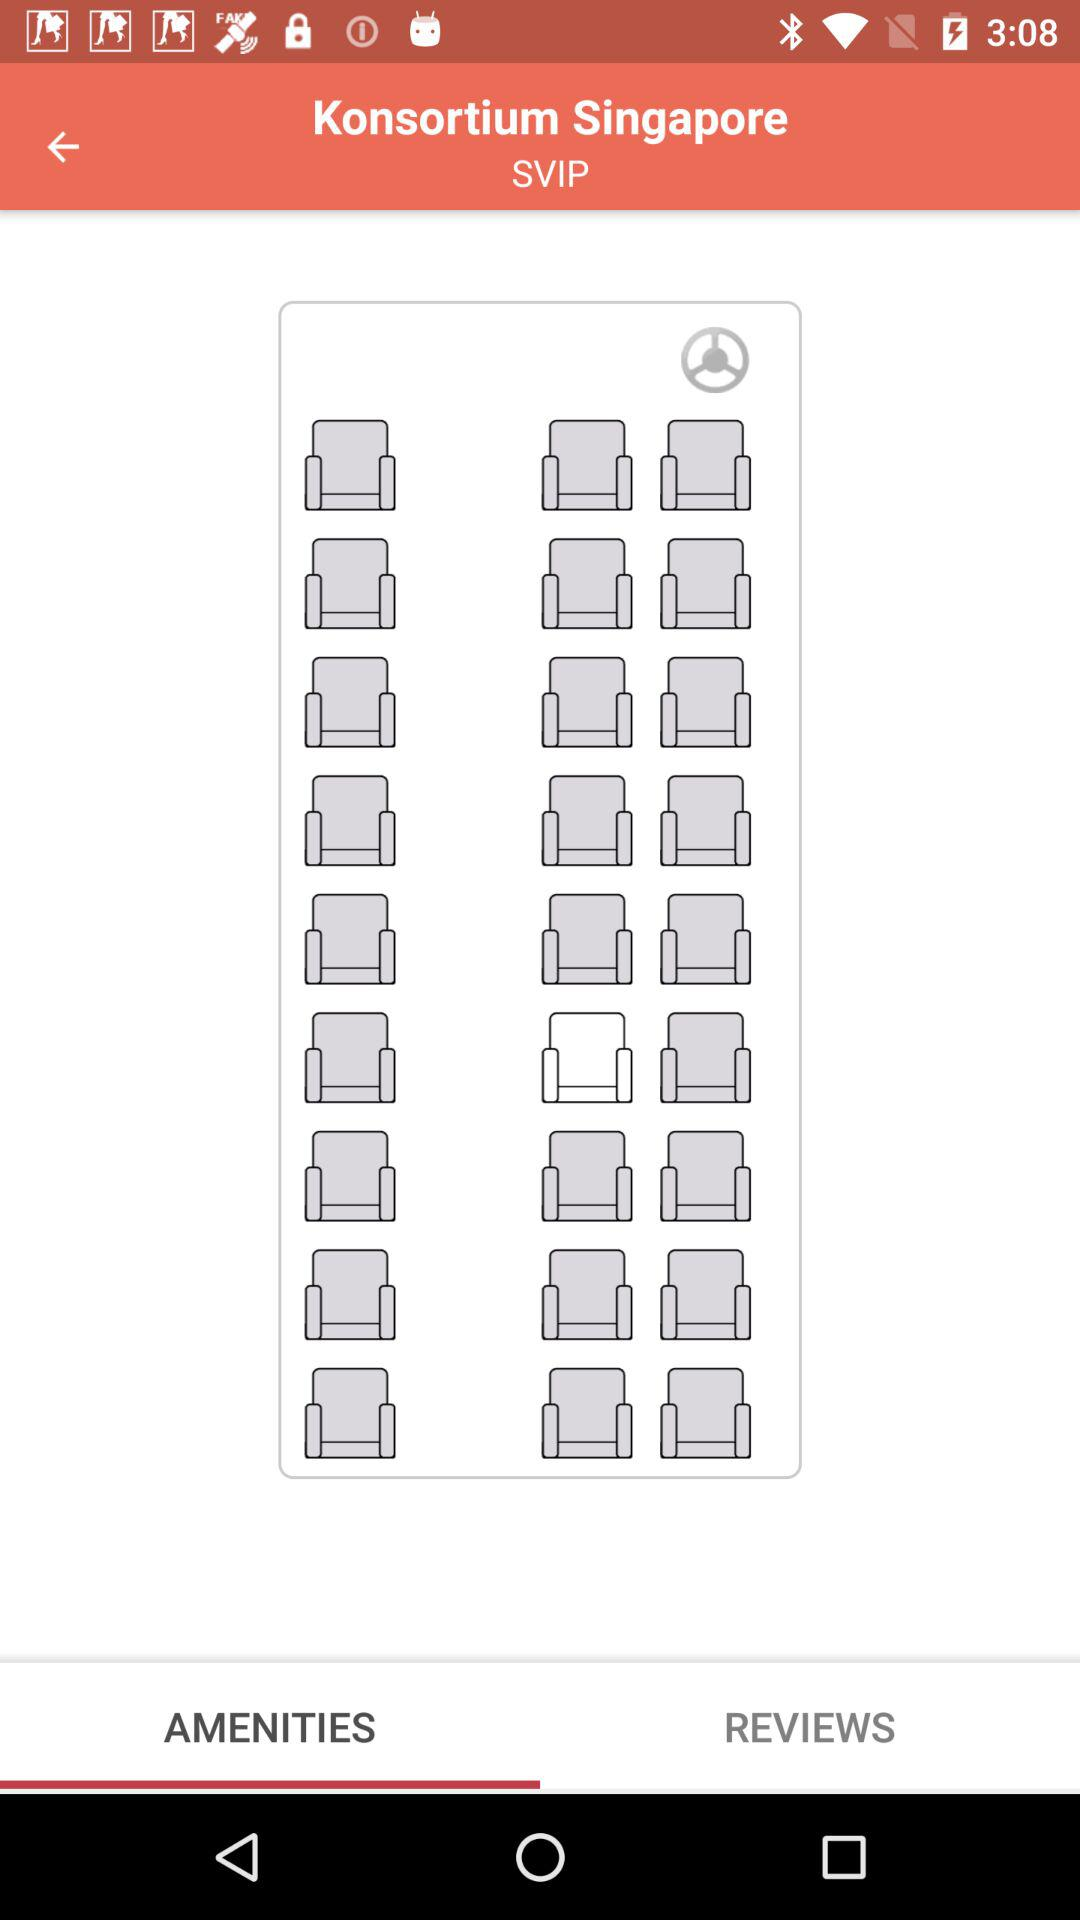Which tab am I using? You are using the "AMENITIES" tab. 